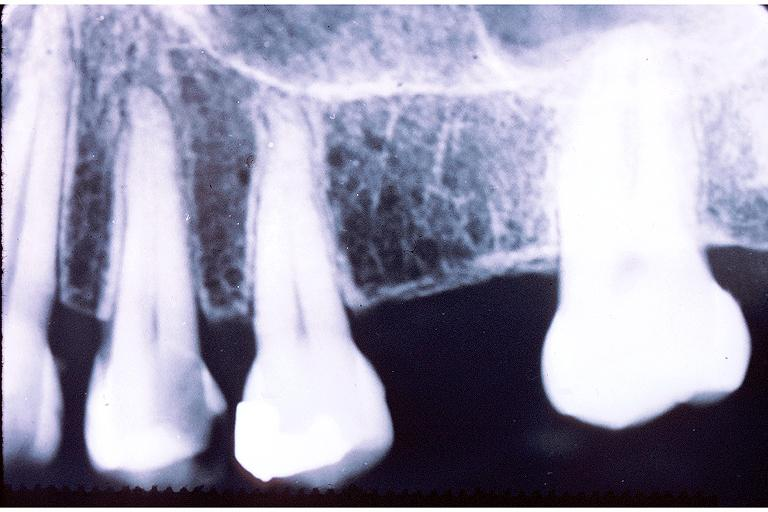what is present?
Answer the question using a single word or phrase. Oral 